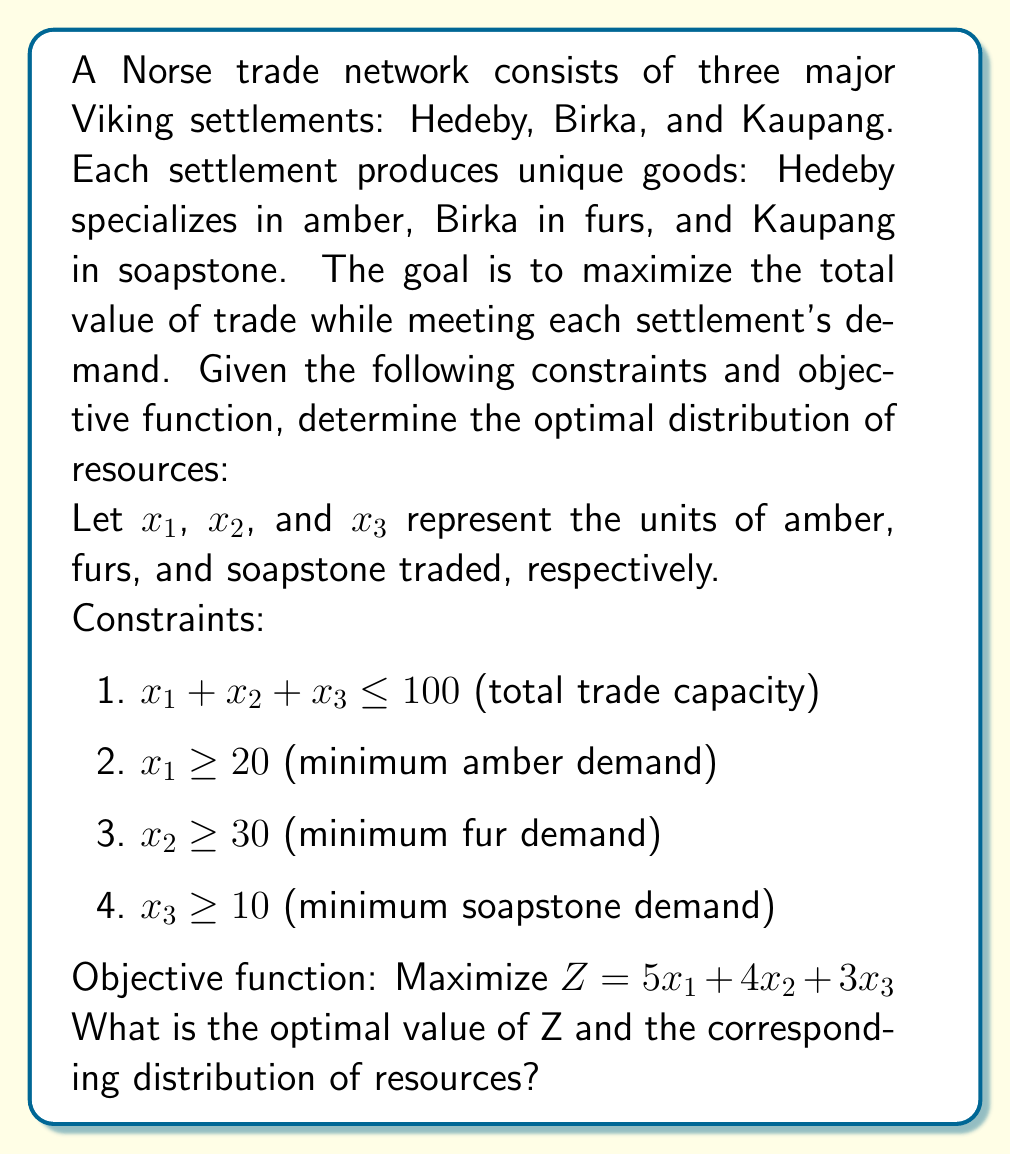Provide a solution to this math problem. To solve this linear programming problem, we'll use the simplex method:

1. Convert inequalities to equations by adding slack variables:
   $x_1 + x_2 + x_3 + s_1 = 100$
   $x_1 - s_2 = 20$
   $x_2 - s_3 = 30$
   $x_3 - s_4 = 10$

2. Set up the initial tableau:

   $$
   \begin{array}{c|cccccccc|c}
               & x_1 & x_2 & x_3 & s_1 & s_2 & s_3 & s_4 & Z & RHS \\
   \hline
   s_1         & 1   & 1   & 1   & 1   & 0   & 0   & 0   & 0 & 100 \\
   s_2         & 1   & 0   & 0   & 0   & -1  & 0   & 0   & 0 & 20  \\
   s_3         & 0   & 1   & 0   & 0   & 0   & -1  & 0   & 0 & 30  \\
   s_4         & 0   & 0   & 1   & 0   & 0   & 0   & -1  & 0 & 10  \\
   \hline
   Z           & -5  & -4  & -3  & 0   & 0   & 0   & 0   & 1 & 0   \\
   \end{array}
   $$

3. Identify the pivot column (most negative in Z row): $x_1$

4. Calculate ratios and identify pivot row:
   $s_1: 100 / 1 = 100$
   $s_2: 20 / 1 = 20$ (pivot row)

5. Perform row operations to get:

   $$
   \begin{array}{c|cccccccc|c}
               & x_1 & x_2 & x_3 & s_1 & s_2 & s_3 & s_4 & Z & RHS \\
   \hline
   x_1         & 1   & 0   & 0   & 0   & -1  & 0   & 0   & 0 & 20  \\
   s_1         & 0   & 1   & 1   & 1   & 1   & 0   & 0   & 0 & 80  \\
   s_3         & 0   & 1   & 0   & 0   & 0   & -1  & 0   & 0 & 30  \\
   s_4         & 0   & 0   & 1   & 0   & 0   & 0   & -1  & 0 & 10  \\
   \hline
   Z           & 0   & -4  & -3  & 0   & 5   & 0   & 0   & 1 & 100 \\
   \end{array}
   $$

6. Repeat steps 3-5 until no negative values remain in Z row:

   Final tableau:
   $$
   \begin{array}{c|cccccccc|c}
               & x_1 & x_2 & x_3 & s_1 & s_2 & s_3 & s_4 & Z & RHS \\
   \hline
   x_1         & 1   & 0   & 0   & 0   & -1  & 0   & 0   & 0 & 20  \\
   x_2         & 0   & 1   & 0   & 0   & 0   & -1  & 0   & 0 & 30  \\
   x_3         & 0   & 0   & 1   & 0   & 0   & 0   & -1  & 0 & 10  \\
   s_1         & 0   & 0   & 0   & 1   & 1   & 1   & 1   & 0 & 40  \\
   \hline
   Z           & 0   & 0   & 0   & 0   & 5   & 4   & 3   & 1 & 250 \\
   \end{array}
   $$

7. Read the solution:
   $x_1 = 20$ (amber)
   $x_2 = 30$ (furs)
   $x_3 = 10$ (soapstone)
   $Z = 250$ (maximum value)
Answer: $Z = 250$; Amber: 20, Furs: 30, Soapstone: 10 